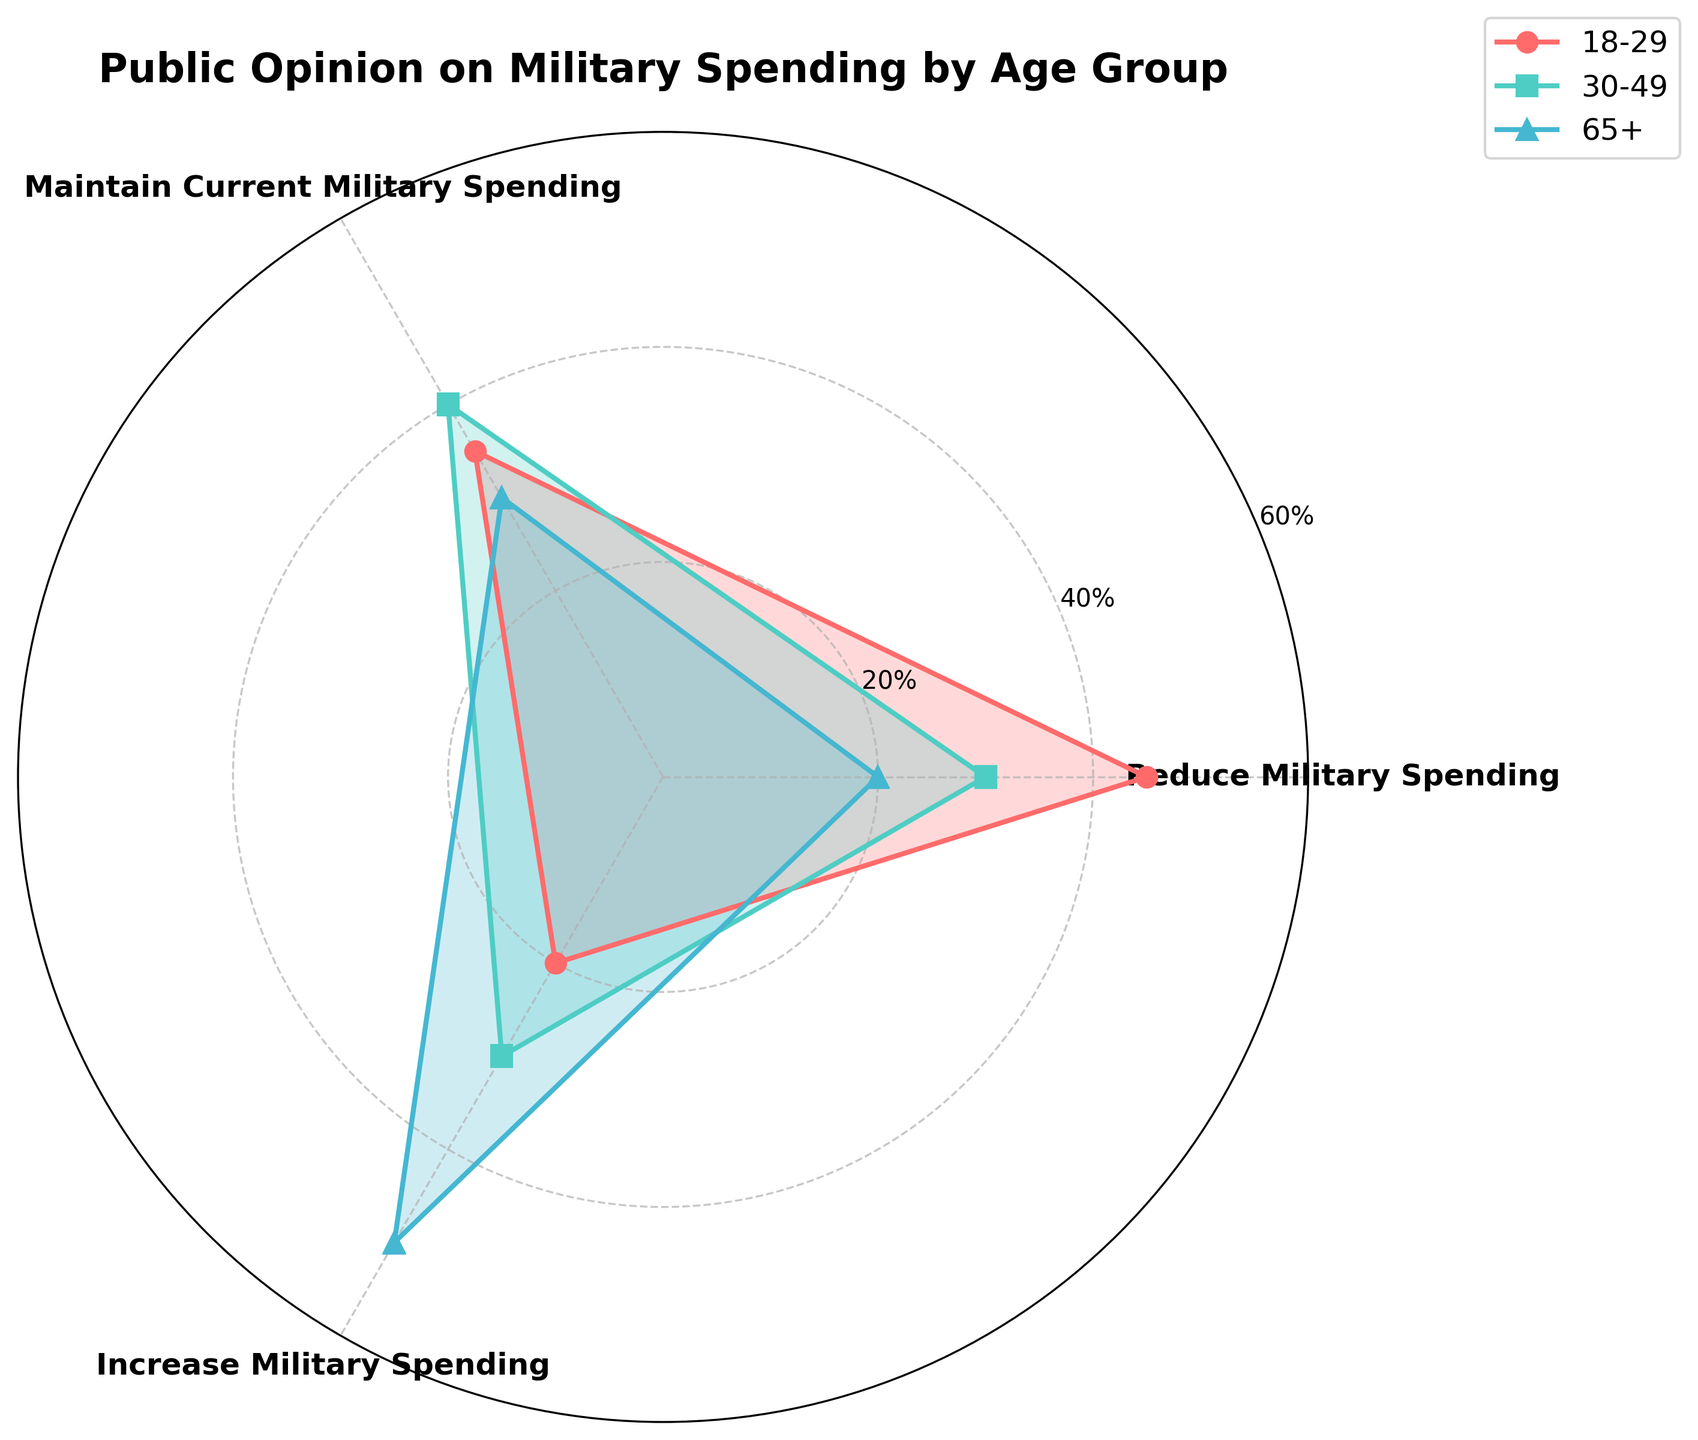What is the title of the radar chart? The title is usually displayed at the top of the chart and summarizes the topic covered by the data. In this case, the title is shown as "Public Opinion on Military Spending by Age Group".
Answer: Public Opinion on Military Spending by Age Group Which age group has the highest percentage of people favoring increased military spending? The plot uses different colors and markers for each age group. The age group with the highest point on the 'Increase Military Spending' axis is found by identifying the highest line segment.
Answer: 65+ What is the difference in percentage between the 'Reduce Military Spending' and 'Increase Military Spending' preferences for the 30-49 age group? Check the values for the 'Reduce Military Spending' and 'Increase Military Spending' categories for the 30-49 age group and subtract the latter from the former. Values are 30% for Reduce and 30% for Increase.
Answer: 0% How do the 'Maintain Current Military Spending' views compare between the 18-29 and 65+ age groups? Look at the respective points on the 'Maintain Current Military Spending' axis for both the 18-29 and 65+ age groups. Compare these values to determine the difference.
Answer: 35% vs. 30% Which age group shows high uniformity in their opinions across all categories? Uniformity can be assessed by comparing the dispersion of points in the radar chart for each age group. The group with the most consistently positioned points across all axes shows the highest uniformity.
Answer: 18-29 What are the combined percentages for 'Reduce Military Spending' and 'Maintain Current Military Spending' for the 18-29 age group? Sum the values of 'Reduce Military Spending' and 'Maintain Current Military Spending' for the 18-29 age group: 45% + 35%.
Answer: 80% Which age group has the smallest variance in their opinions on military spending? Variance can be approximated by visually assessing the spread of the plotted points for each age group. The group with the closest values across categories has the smallest variance.
Answer: 18-29 How does the support for 'Increase Military Spending' change as age increases? Look at the 'Increase Military Spending' values for each age group in ascending age order (18-29, 30-49, 50-64, and 65+). Observe the trend of these values.
Answer: It increases with age What is the percentage difference between 'Reduce Military Spending' preferences of the 50-64 and 65+ age groups? Subtract the 'Reduce Military Spending' value of the 65+ group (20%) from that of the 50-64 group (25%).
Answer: 5% What are the three categories shown in the radar chart? Identify the labels at the vertices of the radar chart. These categories represent different stances on military spending: 'Reduce Military Spending', 'Maintain Current Military Spending', and 'Increase Military Spending'.
Answer: Reduce Military Spending, Maintain Current Military Spending, Increase Military Spending 